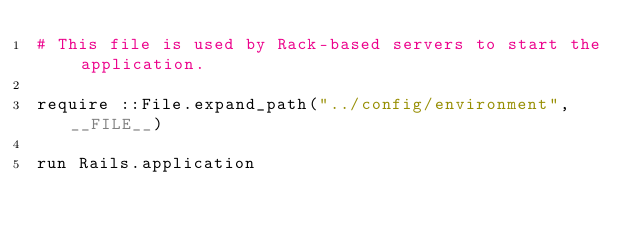Convert code to text. <code><loc_0><loc_0><loc_500><loc_500><_Ruby_># This file is used by Rack-based servers to start the application.

require ::File.expand_path("../config/environment", __FILE__)

run Rails.application
</code> 